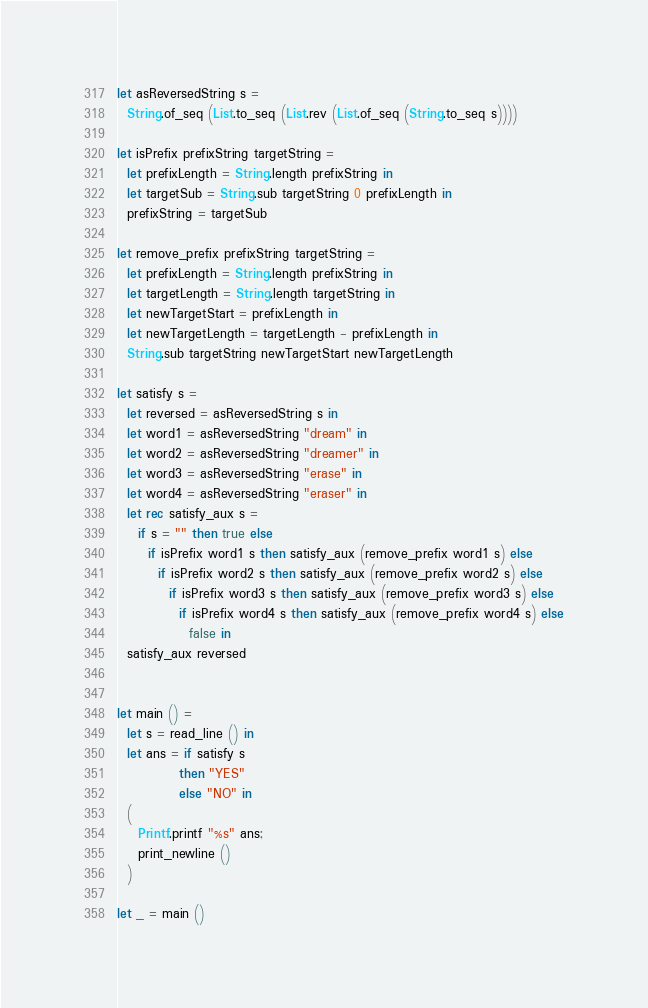Convert code to text. <code><loc_0><loc_0><loc_500><loc_500><_OCaml_>let asReversedString s =
  String.of_seq (List.to_seq (List.rev (List.of_seq (String.to_seq s))))

let isPrefix prefixString targetString =
  let prefixLength = String.length prefixString in
  let targetSub = String.sub targetString 0 prefixLength in
  prefixString = targetSub

let remove_prefix prefixString targetString =
  let prefixLength = String.length prefixString in
  let targetLength = String.length targetString in
  let newTargetStart = prefixLength in 
  let newTargetLength = targetLength - prefixLength in
  String.sub targetString newTargetStart newTargetLength

let satisfy s =
  let reversed = asReversedString s in
  let word1 = asReversedString "dream" in
  let word2 = asReversedString "dreamer" in
  let word3 = asReversedString "erase" in
  let word4 = asReversedString "eraser" in
  let rec satisfy_aux s =
    if s = "" then true else
      if isPrefix word1 s then satisfy_aux (remove_prefix word1 s) else
        if isPrefix word2 s then satisfy_aux (remove_prefix word2 s) else
          if isPrefix word3 s then satisfy_aux (remove_prefix word3 s) else
            if isPrefix word4 s then satisfy_aux (remove_prefix word4 s) else
              false in
  satisfy_aux reversed
    

let main () =
  let s = read_line () in
  let ans = if satisfy s
            then "YES"
            else "NO" in
  (
    Printf.printf "%s" ans;
    print_newline ()
  )

let _ = main ()
</code> 